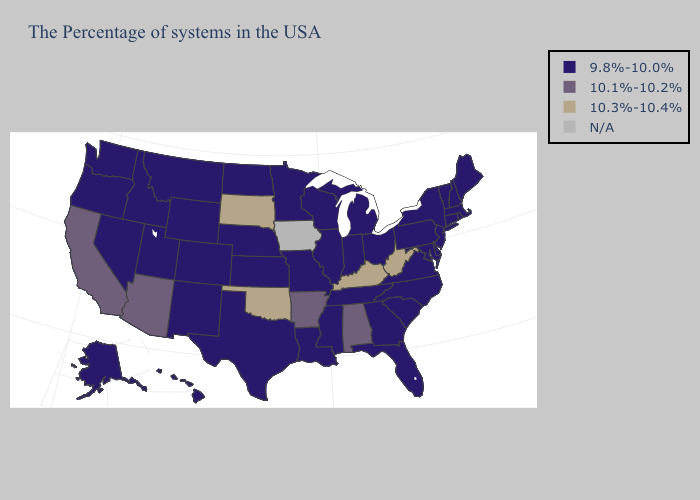Name the states that have a value in the range N/A?
Keep it brief. Iowa. Does the map have missing data?
Be succinct. Yes. Does Nebraska have the lowest value in the USA?
Concise answer only. Yes. What is the value of Wyoming?
Be succinct. 9.8%-10.0%. Among the states that border Montana , does South Dakota have the highest value?
Concise answer only. Yes. What is the value of Rhode Island?
Short answer required. 9.8%-10.0%. Name the states that have a value in the range N/A?
Short answer required. Iowa. What is the value of Idaho?
Keep it brief. 9.8%-10.0%. What is the value of Washington?
Be succinct. 9.8%-10.0%. Name the states that have a value in the range 9.8%-10.0%?
Answer briefly. Maine, Massachusetts, Rhode Island, New Hampshire, Vermont, Connecticut, New York, New Jersey, Delaware, Maryland, Pennsylvania, Virginia, North Carolina, South Carolina, Ohio, Florida, Georgia, Michigan, Indiana, Tennessee, Wisconsin, Illinois, Mississippi, Louisiana, Missouri, Minnesota, Kansas, Nebraska, Texas, North Dakota, Wyoming, Colorado, New Mexico, Utah, Montana, Idaho, Nevada, Washington, Oregon, Alaska, Hawaii. Among the states that border Louisiana , which have the highest value?
Quick response, please. Arkansas. Does New Mexico have the highest value in the West?
Quick response, please. No. What is the highest value in states that border South Carolina?
Short answer required. 9.8%-10.0%. Among the states that border Illinois , which have the highest value?
Concise answer only. Kentucky. 